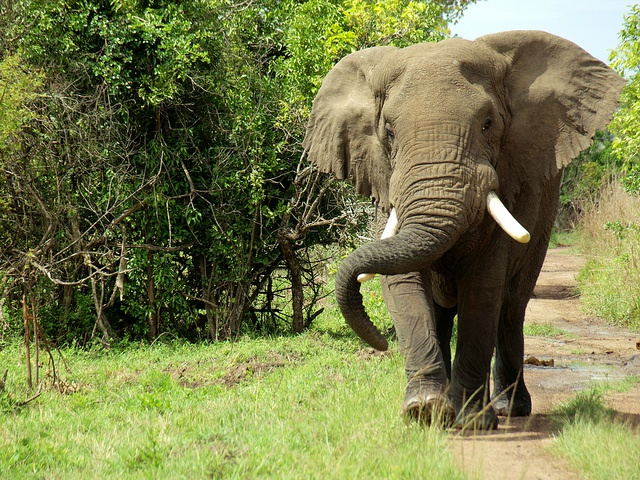Describe the objects in this image and their specific colors. I can see a elephant in darkgreen, black, tan, and gray tones in this image. 